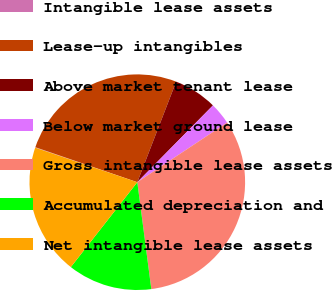<chart> <loc_0><loc_0><loc_500><loc_500><pie_chart><fcel>Intangible lease assets<fcel>Lease-up intangibles<fcel>Above market tenant lease<fcel>Below market ground lease<fcel>Gross intangible lease assets<fcel>Accumulated depreciation and<fcel>Net intangible lease assets<nl><fcel>0.07%<fcel>25.61%<fcel>6.51%<fcel>3.29%<fcel>32.26%<fcel>12.65%<fcel>19.62%<nl></chart> 